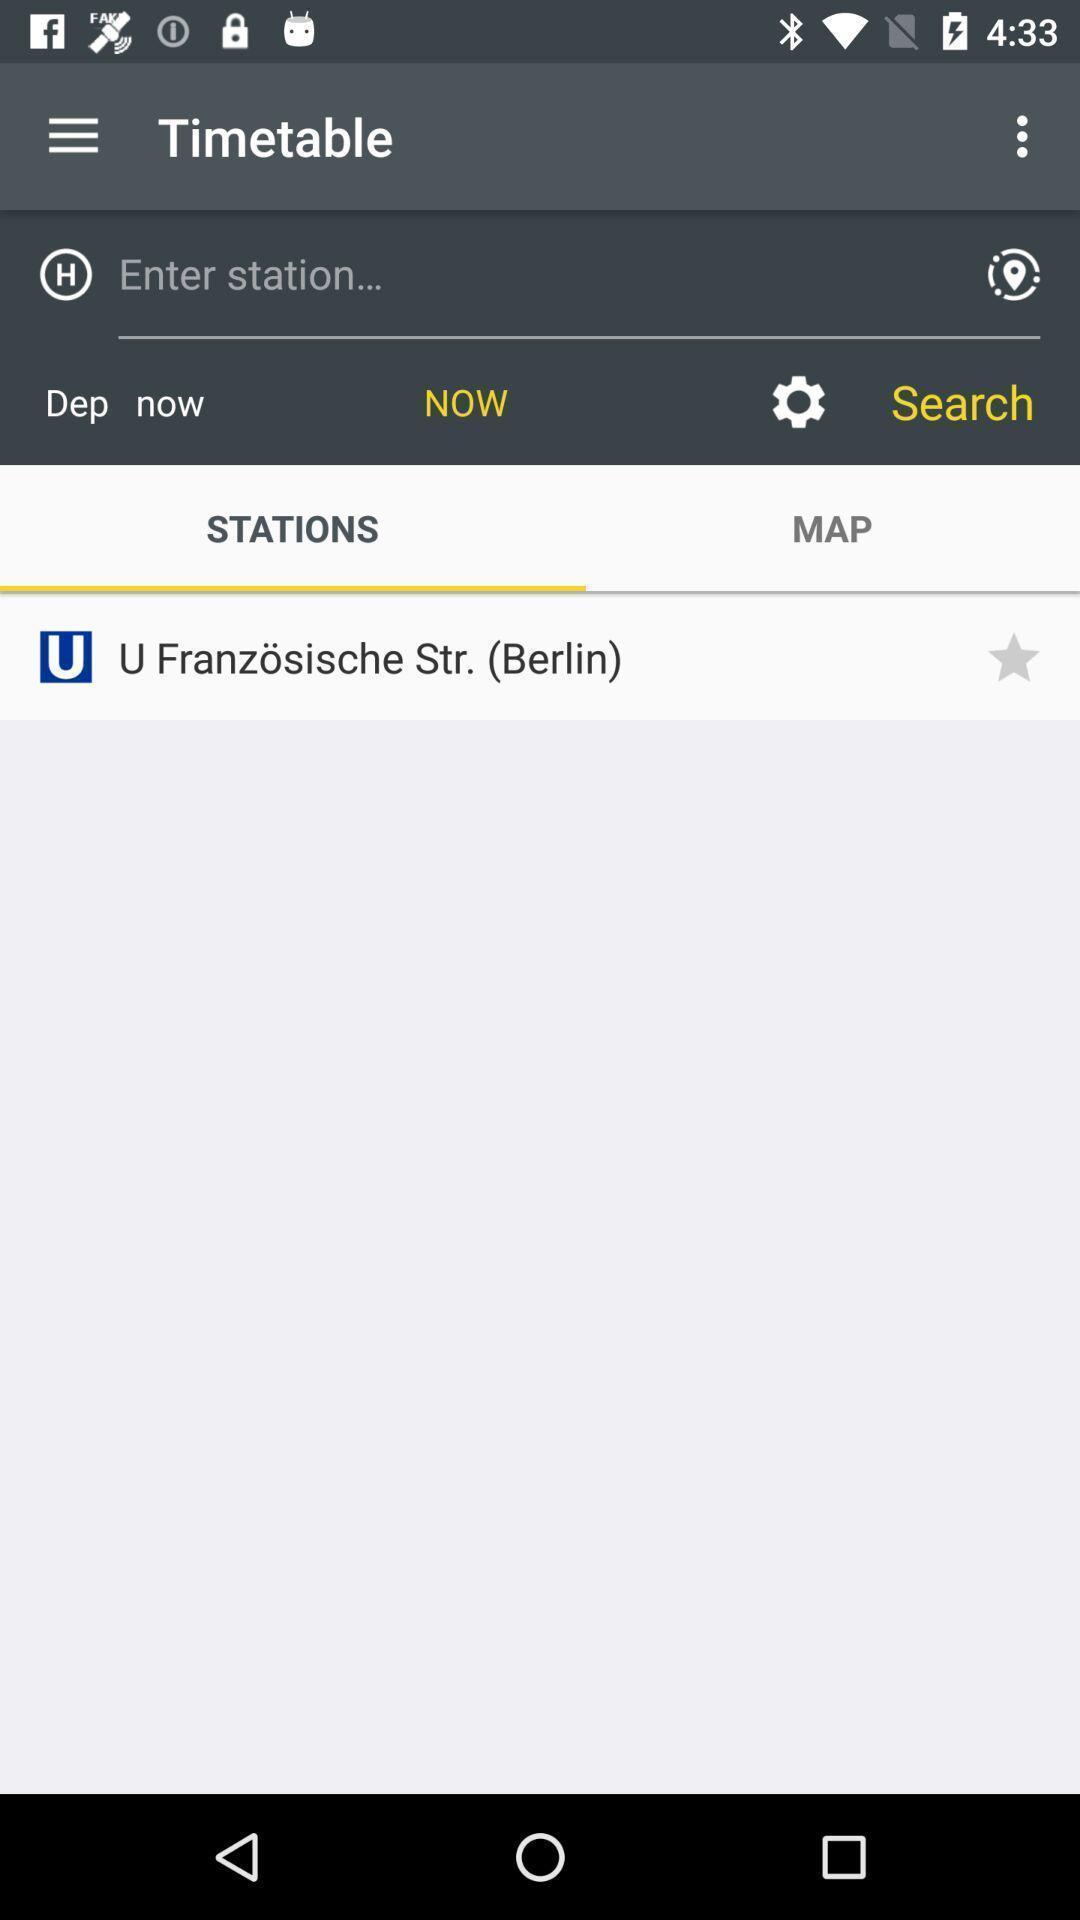Describe this image in words. Search bar showing in gps application. 